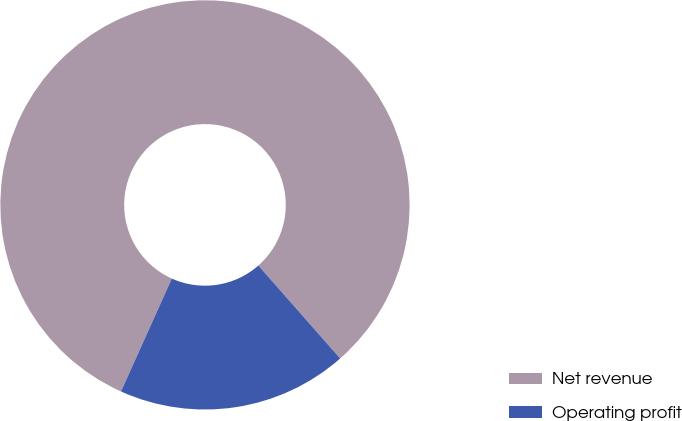Convert chart. <chart><loc_0><loc_0><loc_500><loc_500><pie_chart><fcel>Net revenue<fcel>Operating profit<nl><fcel>81.78%<fcel>18.22%<nl></chart> 